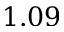<formula> <loc_0><loc_0><loc_500><loc_500>1 . 0 9</formula> 